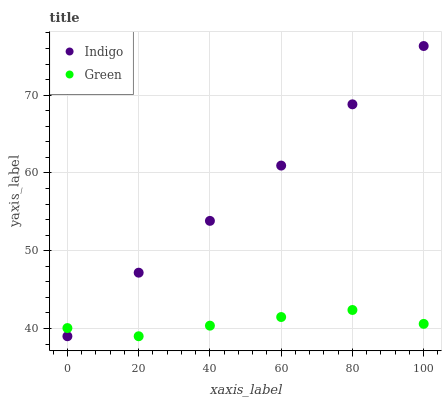Does Green have the minimum area under the curve?
Answer yes or no. Yes. Does Indigo have the maximum area under the curve?
Answer yes or no. Yes. Does Indigo have the minimum area under the curve?
Answer yes or no. No. Is Indigo the smoothest?
Answer yes or no. Yes. Is Green the roughest?
Answer yes or no. Yes. Is Indigo the roughest?
Answer yes or no. No. Does Green have the lowest value?
Answer yes or no. Yes. Does Indigo have the highest value?
Answer yes or no. Yes. Does Indigo intersect Green?
Answer yes or no. Yes. Is Indigo less than Green?
Answer yes or no. No. Is Indigo greater than Green?
Answer yes or no. No. 